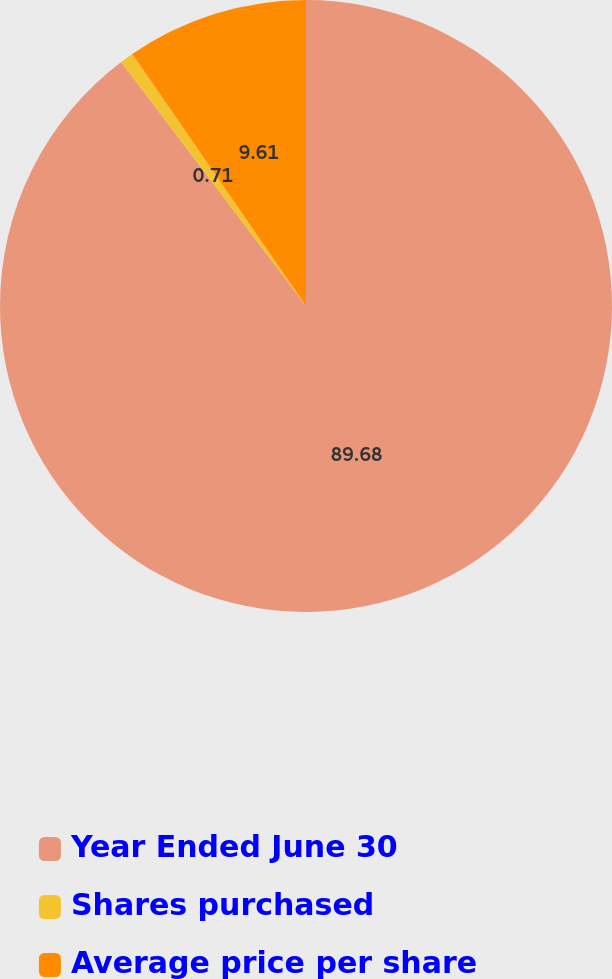Convert chart to OTSL. <chart><loc_0><loc_0><loc_500><loc_500><pie_chart><fcel>Year Ended June 30<fcel>Shares purchased<fcel>Average price per share<nl><fcel>89.68%<fcel>0.71%<fcel>9.61%<nl></chart> 